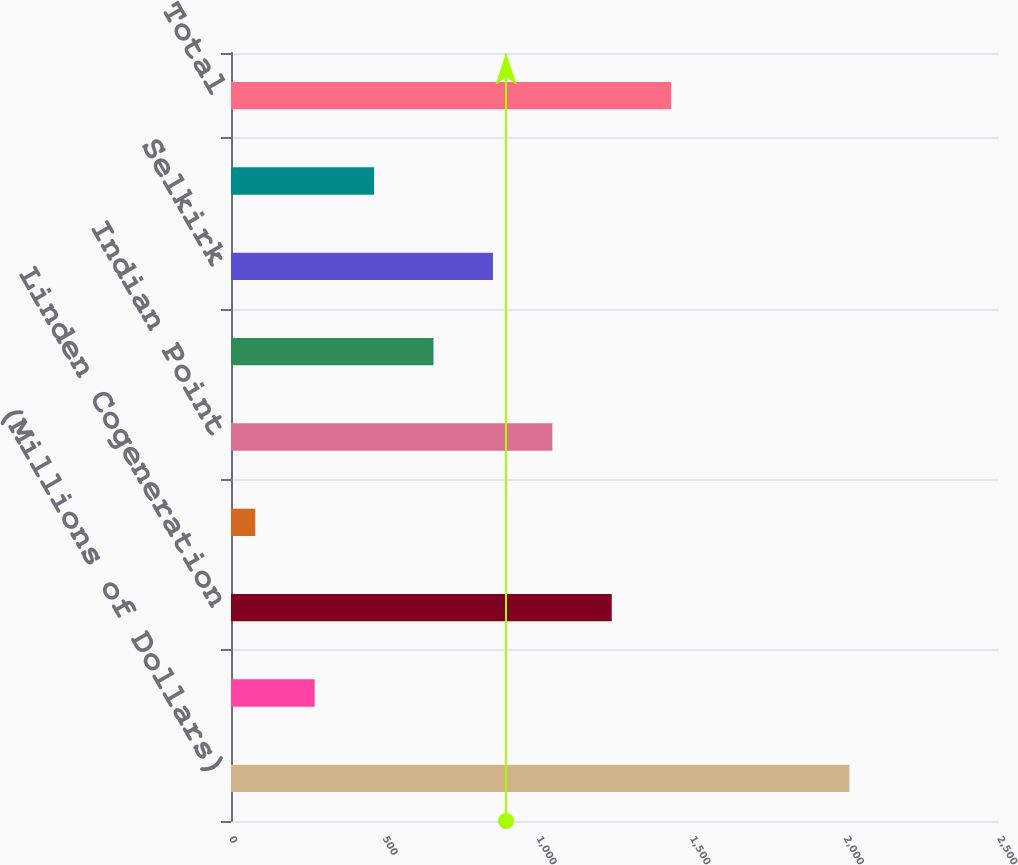<chart> <loc_0><loc_0><loc_500><loc_500><bar_chart><fcel>(Millions of Dollars)<fcel>Brooklyn Navy Yard<fcel>Linden Cogeneration<fcel>Indeck Corinth<fcel>Indian Point<fcel>Astoria Energy<fcel>Selkirk<fcel>Independence<fcel>Total<nl><fcel>2013<fcel>272.4<fcel>1239.4<fcel>79<fcel>1046<fcel>659.2<fcel>852.6<fcel>465.8<fcel>1432.8<nl></chart> 